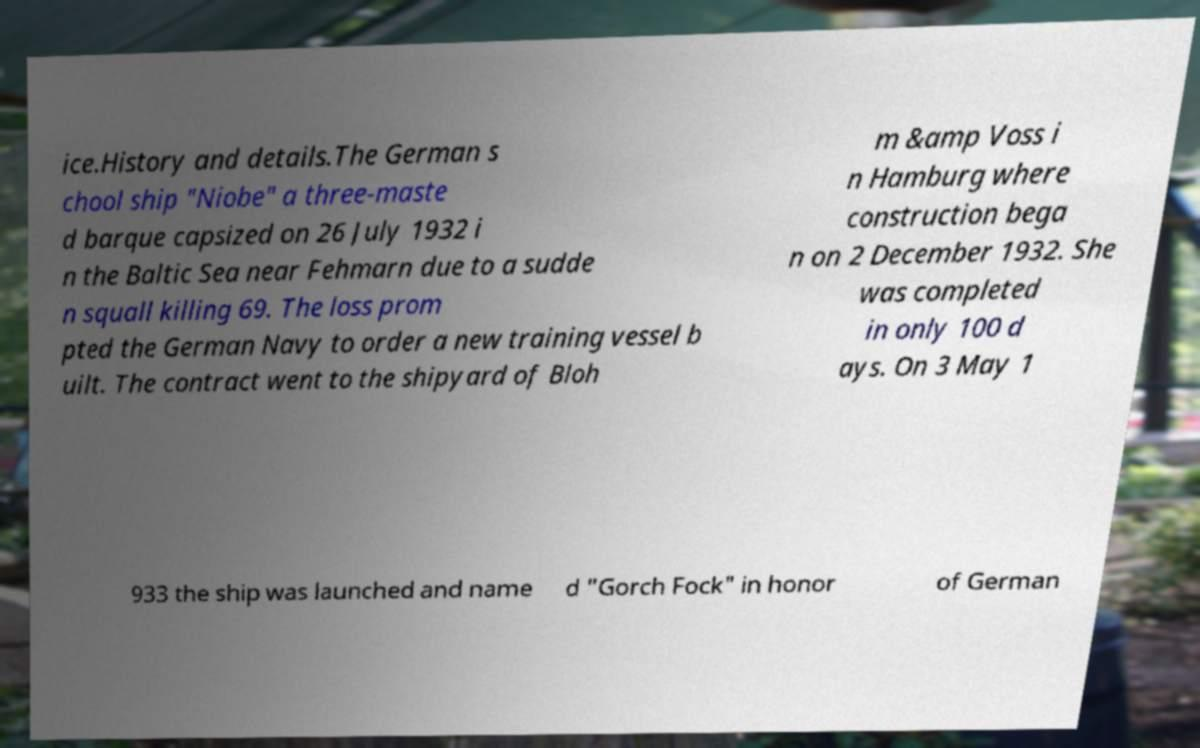For documentation purposes, I need the text within this image transcribed. Could you provide that? ice.History and details.The German s chool ship "Niobe" a three-maste d barque capsized on 26 July 1932 i n the Baltic Sea near Fehmarn due to a sudde n squall killing 69. The loss prom pted the German Navy to order a new training vessel b uilt. The contract went to the shipyard of Bloh m &amp Voss i n Hamburg where construction bega n on 2 December 1932. She was completed in only 100 d ays. On 3 May 1 933 the ship was launched and name d "Gorch Fock" in honor of German 